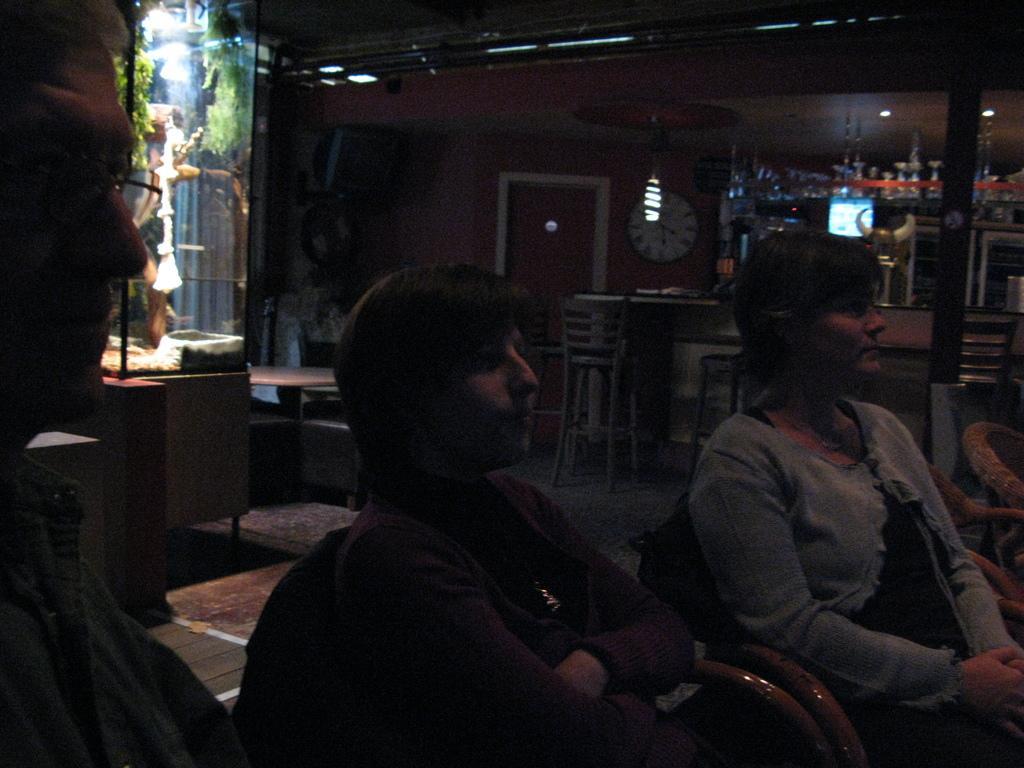In one or two sentences, can you explain what this image depicts? In the front of the image people are sitting on chairs. In the background of the image we can see chairs, tables, rack, door, television, clock, lights, plants, glass and things. 